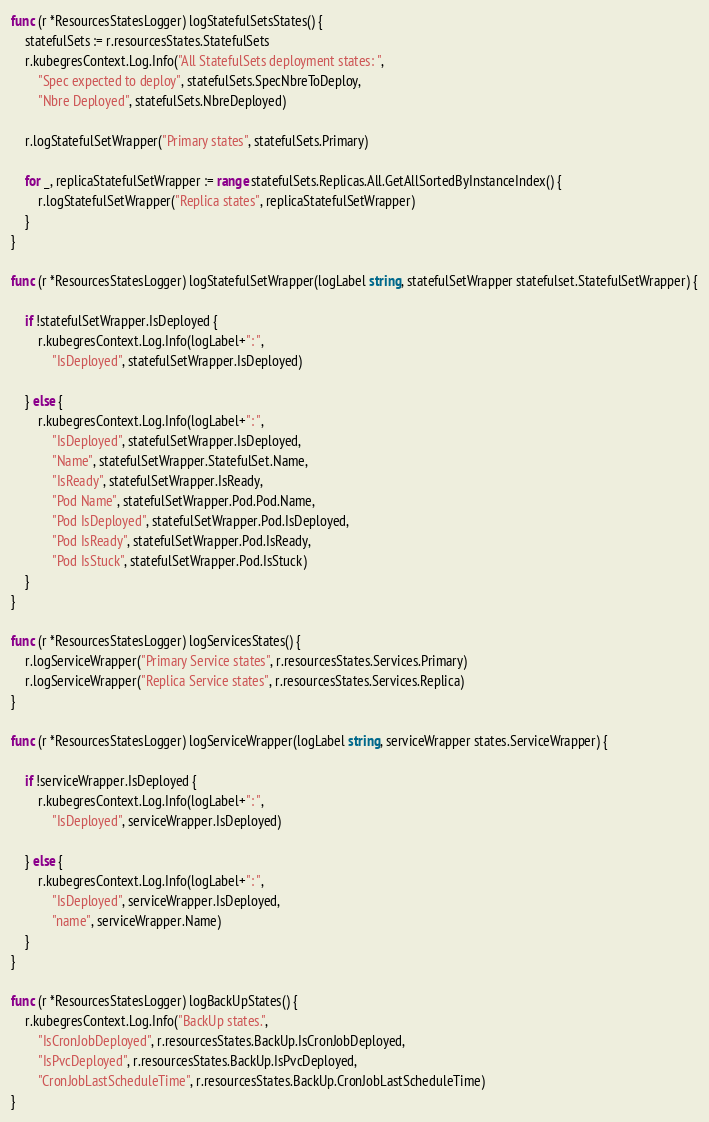<code> <loc_0><loc_0><loc_500><loc_500><_Go_>func (r *ResourcesStatesLogger) logStatefulSetsStates() {
	statefulSets := r.resourcesStates.StatefulSets
	r.kubegresContext.Log.Info("All StatefulSets deployment states: ",
		"Spec expected to deploy", statefulSets.SpecNbreToDeploy,
		"Nbre Deployed", statefulSets.NbreDeployed)

	r.logStatefulSetWrapper("Primary states", statefulSets.Primary)

	for _, replicaStatefulSetWrapper := range statefulSets.Replicas.All.GetAllSortedByInstanceIndex() {
		r.logStatefulSetWrapper("Replica states", replicaStatefulSetWrapper)
	}
}

func (r *ResourcesStatesLogger) logStatefulSetWrapper(logLabel string, statefulSetWrapper statefulset.StatefulSetWrapper) {

	if !statefulSetWrapper.IsDeployed {
		r.kubegresContext.Log.Info(logLabel+": ",
			"IsDeployed", statefulSetWrapper.IsDeployed)

	} else {
		r.kubegresContext.Log.Info(logLabel+": ",
			"IsDeployed", statefulSetWrapper.IsDeployed,
			"Name", statefulSetWrapper.StatefulSet.Name,
			"IsReady", statefulSetWrapper.IsReady,
			"Pod Name", statefulSetWrapper.Pod.Pod.Name,
			"Pod IsDeployed", statefulSetWrapper.Pod.IsDeployed,
			"Pod IsReady", statefulSetWrapper.Pod.IsReady,
			"Pod IsStuck", statefulSetWrapper.Pod.IsStuck)
	}
}

func (r *ResourcesStatesLogger) logServicesStates() {
	r.logServiceWrapper("Primary Service states", r.resourcesStates.Services.Primary)
	r.logServiceWrapper("Replica Service states", r.resourcesStates.Services.Replica)
}

func (r *ResourcesStatesLogger) logServiceWrapper(logLabel string, serviceWrapper states.ServiceWrapper) {

	if !serviceWrapper.IsDeployed {
		r.kubegresContext.Log.Info(logLabel+": ",
			"IsDeployed", serviceWrapper.IsDeployed)

	} else {
		r.kubegresContext.Log.Info(logLabel+": ",
			"IsDeployed", serviceWrapper.IsDeployed,
			"name", serviceWrapper.Name)
	}
}

func (r *ResourcesStatesLogger) logBackUpStates() {
	r.kubegresContext.Log.Info("BackUp states.",
		"IsCronJobDeployed", r.resourcesStates.BackUp.IsCronJobDeployed,
		"IsPvcDeployed", r.resourcesStates.BackUp.IsPvcDeployed,
		"CronJobLastScheduleTime", r.resourcesStates.BackUp.CronJobLastScheduleTime)
}
</code> 